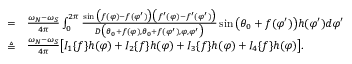Convert formula to latex. <formula><loc_0><loc_0><loc_500><loc_500>\begin{array} { r l } { = } & \frac { \omega _ { N } - \omega _ { S } } { 4 \pi } \int _ { 0 } ^ { 2 \pi } \frac { \sin \left ( f ( \varphi ) - f ( \varphi ^ { \prime } ) \right ) \left ( f ^ { \prime } ( \varphi ) - f ^ { \prime } ( \varphi ^ { \prime } ) \right ) } { D \left ( \theta _ { 0 } + f ( \varphi ) , \theta _ { 0 } + f ( \varphi ^ { \prime } ) , \varphi , \varphi ^ { \prime } \right ) } \sin \left ( \theta _ { 0 } + f ( \varphi ^ { \prime } ) \right ) h ( \varphi ^ { \prime } ) d \varphi ^ { \prime } } \\ { \triangle q } & \frac { \omega _ { N } - \omega _ { S } } { 4 \pi } \left [ I _ { 1 } \{ f \} h ( \varphi ) + I _ { 2 } \{ f \} h ( \varphi ) + I _ { 3 } \{ f \} h ( \varphi ) + I _ { 4 } \{ f \} h ( \varphi ) \right ] . } \end{array}</formula> 